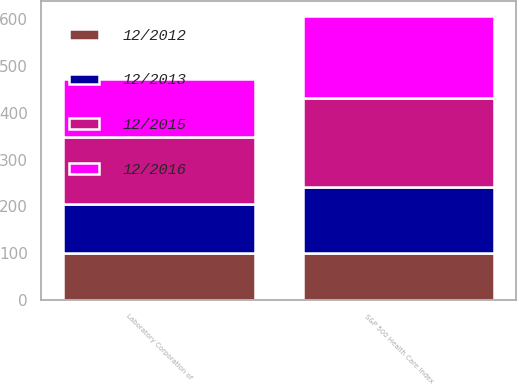Convert chart. <chart><loc_0><loc_0><loc_500><loc_500><stacked_bar_chart><ecel><fcel>Laboratory Corporation of<fcel>S&P 500 Health Care Index<nl><fcel>12/2012<fcel>100<fcel>100<nl><fcel>12/2013<fcel>105.48<fcel>141.46<nl><fcel>12/2016<fcel>124.57<fcel>177.3<nl><fcel>12/2015<fcel>142.74<fcel>189.52<nl></chart> 